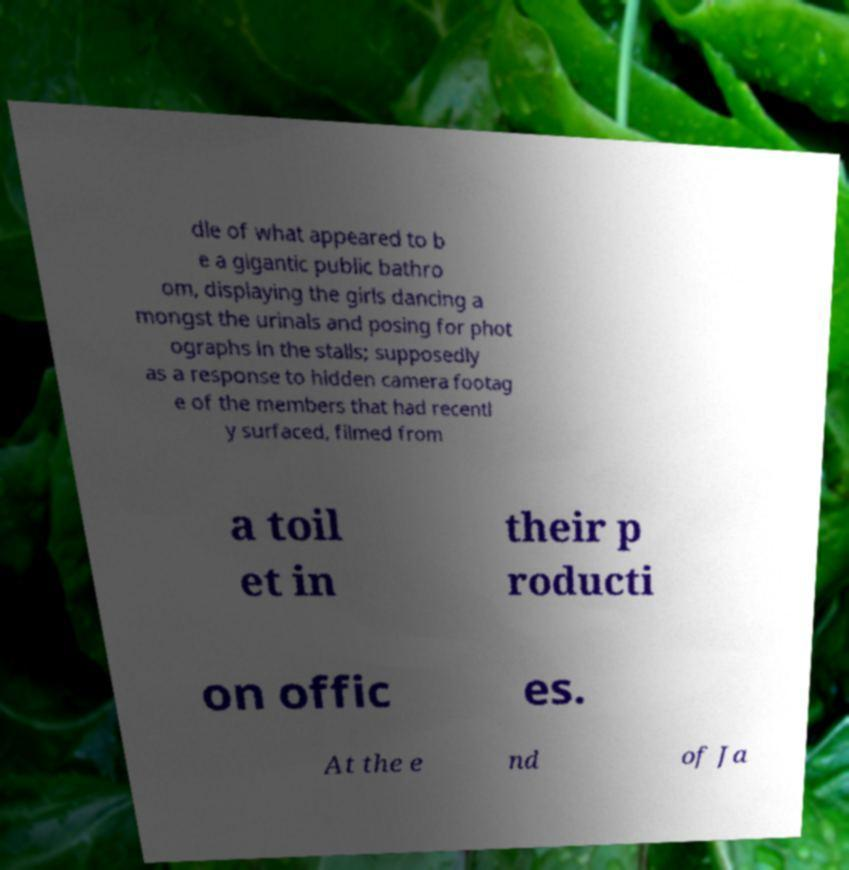Please identify and transcribe the text found in this image. dle of what appeared to b e a gigantic public bathro om, displaying the girls dancing a mongst the urinals and posing for phot ographs in the stalls; supposedly as a response to hidden camera footag e of the members that had recentl y surfaced, filmed from a toil et in their p roducti on offic es. At the e nd of Ja 